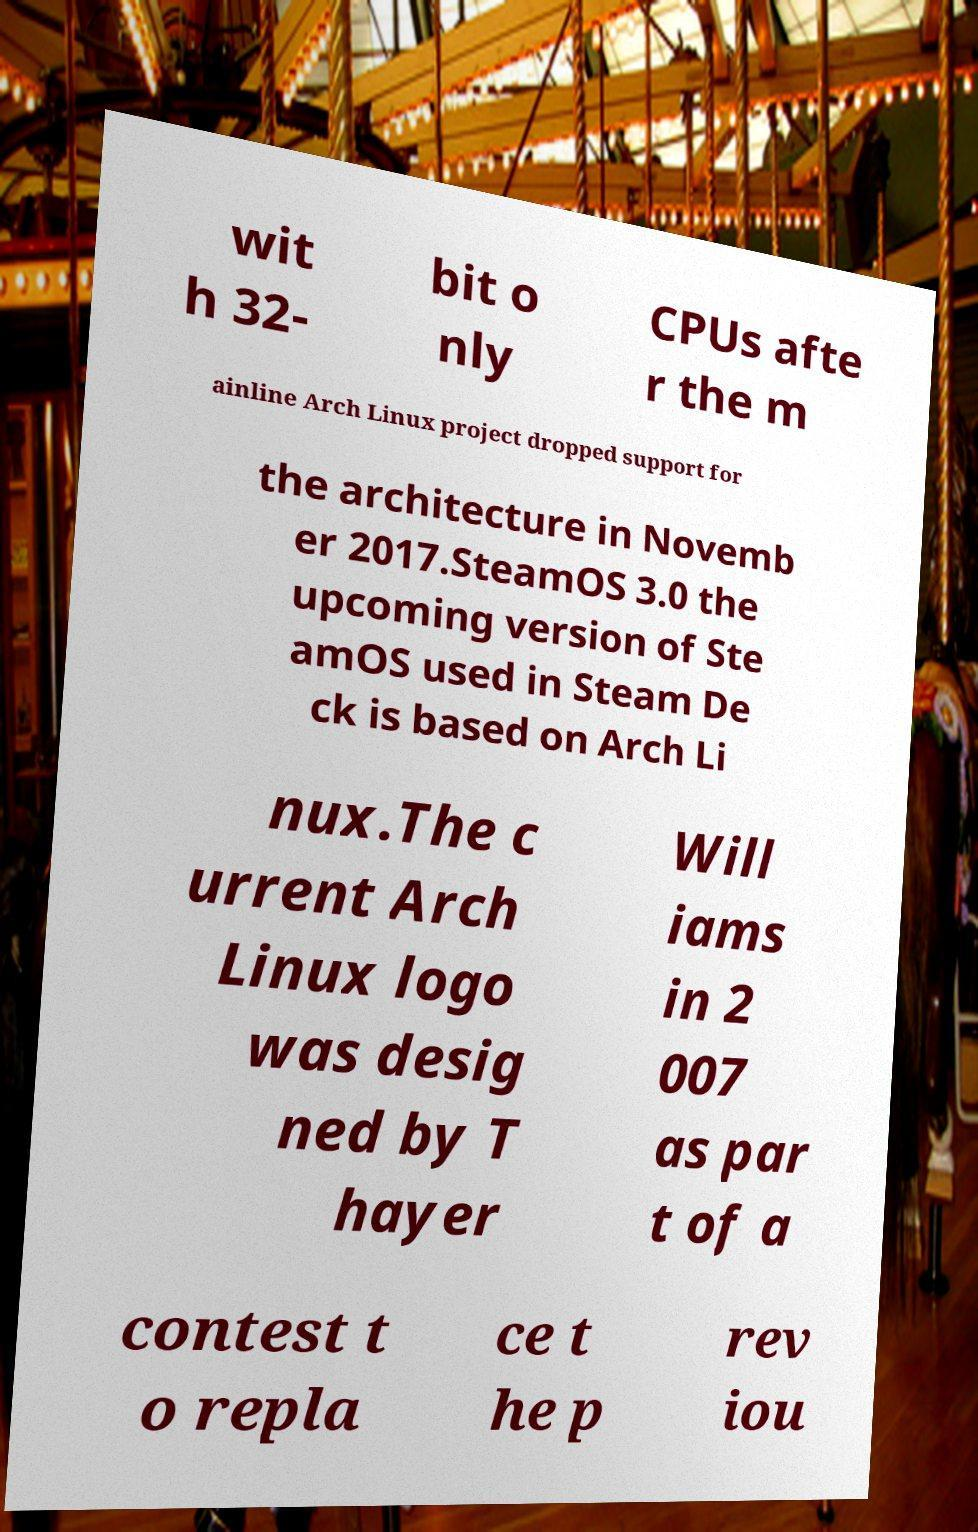I need the written content from this picture converted into text. Can you do that? wit h 32- bit o nly CPUs afte r the m ainline Arch Linux project dropped support for the architecture in Novemb er 2017.SteamOS 3.0 the upcoming version of Ste amOS used in Steam De ck is based on Arch Li nux.The c urrent Arch Linux logo was desig ned by T hayer Will iams in 2 007 as par t of a contest t o repla ce t he p rev iou 